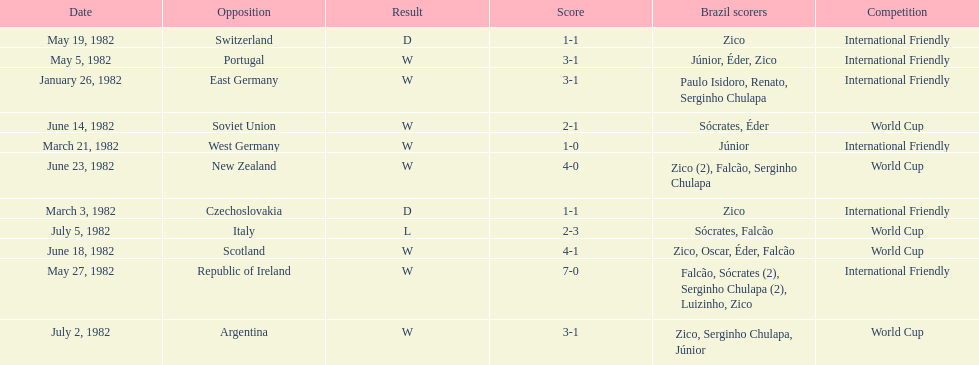Who won on january 26, 1982 and may 27, 1982? Brazil. 